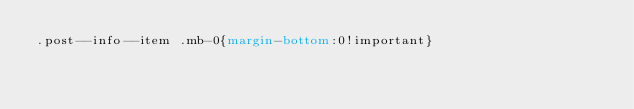Convert code to text. <code><loc_0><loc_0><loc_500><loc_500><_CSS_>.post--info--item .mb-0{margin-bottom:0!important}</code> 